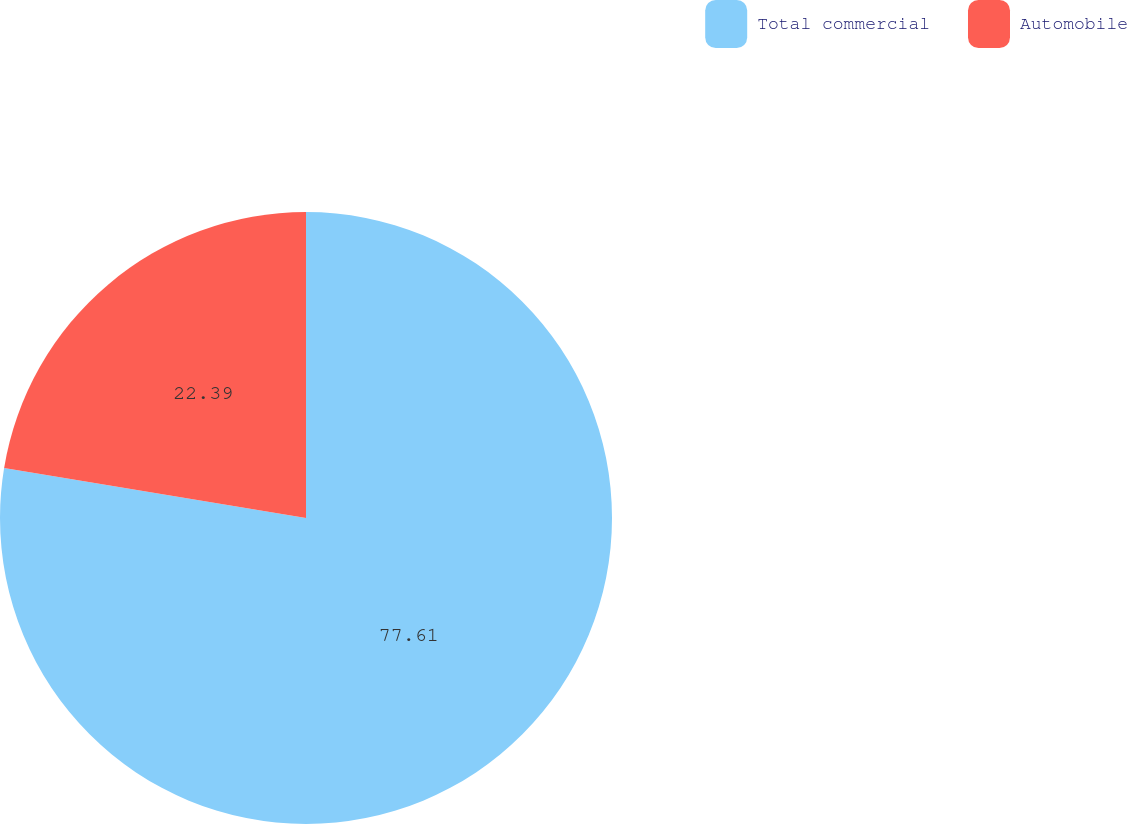Convert chart. <chart><loc_0><loc_0><loc_500><loc_500><pie_chart><fcel>Total commercial<fcel>Automobile<nl><fcel>77.61%<fcel>22.39%<nl></chart> 